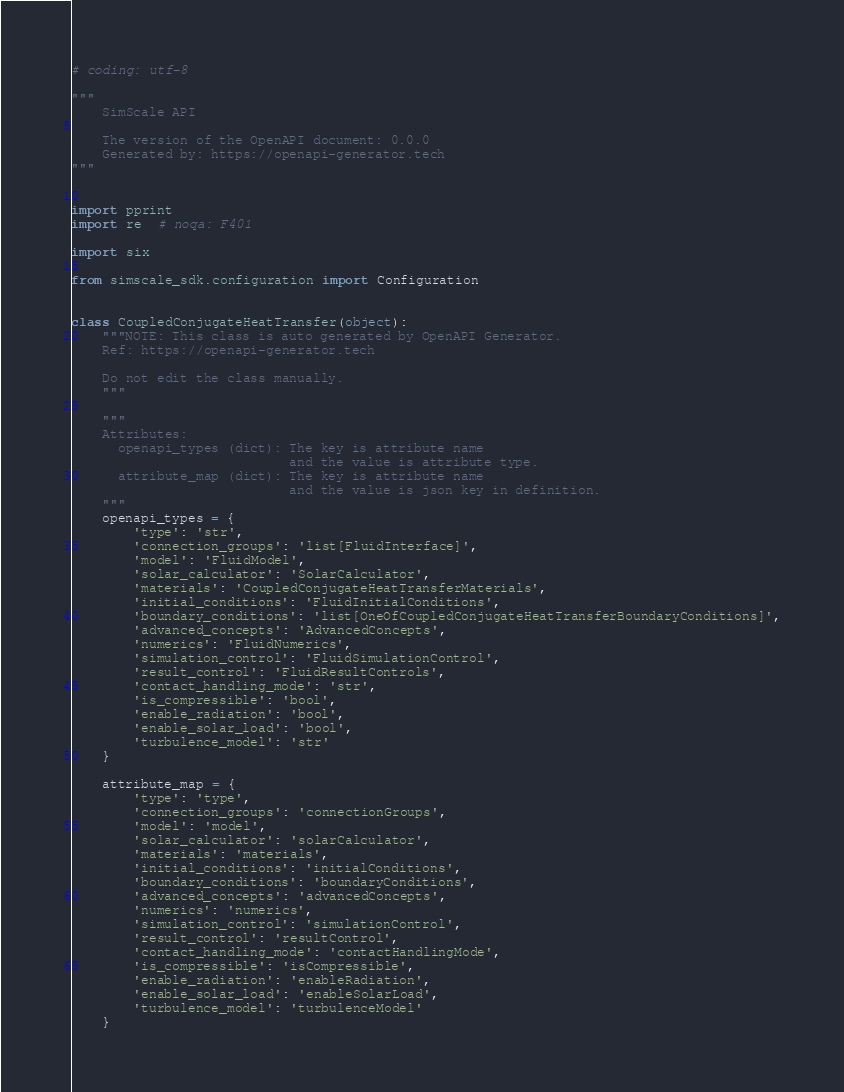Convert code to text. <code><loc_0><loc_0><loc_500><loc_500><_Python_># coding: utf-8

"""
    SimScale API

    The version of the OpenAPI document: 0.0.0
    Generated by: https://openapi-generator.tech
"""


import pprint
import re  # noqa: F401

import six

from simscale_sdk.configuration import Configuration


class CoupledConjugateHeatTransfer(object):
    """NOTE: This class is auto generated by OpenAPI Generator.
    Ref: https://openapi-generator.tech

    Do not edit the class manually.
    """

    """
    Attributes:
      openapi_types (dict): The key is attribute name
                            and the value is attribute type.
      attribute_map (dict): The key is attribute name
                            and the value is json key in definition.
    """
    openapi_types = {
        'type': 'str',
        'connection_groups': 'list[FluidInterface]',
        'model': 'FluidModel',
        'solar_calculator': 'SolarCalculator',
        'materials': 'CoupledConjugateHeatTransferMaterials',
        'initial_conditions': 'FluidInitialConditions',
        'boundary_conditions': 'list[OneOfCoupledConjugateHeatTransferBoundaryConditions]',
        'advanced_concepts': 'AdvancedConcepts',
        'numerics': 'FluidNumerics',
        'simulation_control': 'FluidSimulationControl',
        'result_control': 'FluidResultControls',
        'contact_handling_mode': 'str',
        'is_compressible': 'bool',
        'enable_radiation': 'bool',
        'enable_solar_load': 'bool',
        'turbulence_model': 'str'
    }

    attribute_map = {
        'type': 'type',
        'connection_groups': 'connectionGroups',
        'model': 'model',
        'solar_calculator': 'solarCalculator',
        'materials': 'materials',
        'initial_conditions': 'initialConditions',
        'boundary_conditions': 'boundaryConditions',
        'advanced_concepts': 'advancedConcepts',
        'numerics': 'numerics',
        'simulation_control': 'simulationControl',
        'result_control': 'resultControl',
        'contact_handling_mode': 'contactHandlingMode',
        'is_compressible': 'isCompressible',
        'enable_radiation': 'enableRadiation',
        'enable_solar_load': 'enableSolarLoad',
        'turbulence_model': 'turbulenceModel'
    }
</code> 